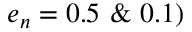<formula> <loc_0><loc_0><loc_500><loc_500>e _ { n } = 0 . 5 \& 0 . 1 )</formula> 